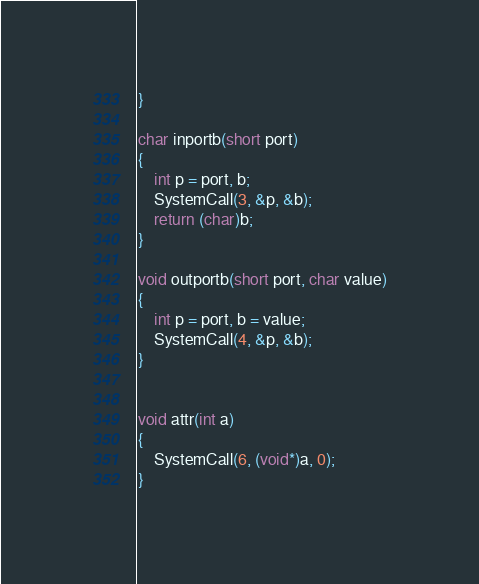<code> <loc_0><loc_0><loc_500><loc_500><_C_>}

char inportb(short port)
{
	int p = port, b;
	SystemCall(3, &p, &b);
	return (char)b;
}

void outportb(short port, char value)
{
	int p = port, b = value;
	SystemCall(4, &p, &b);
}


void attr(int a)
{
	SystemCall(6, (void*)a, 0);
}

</code> 